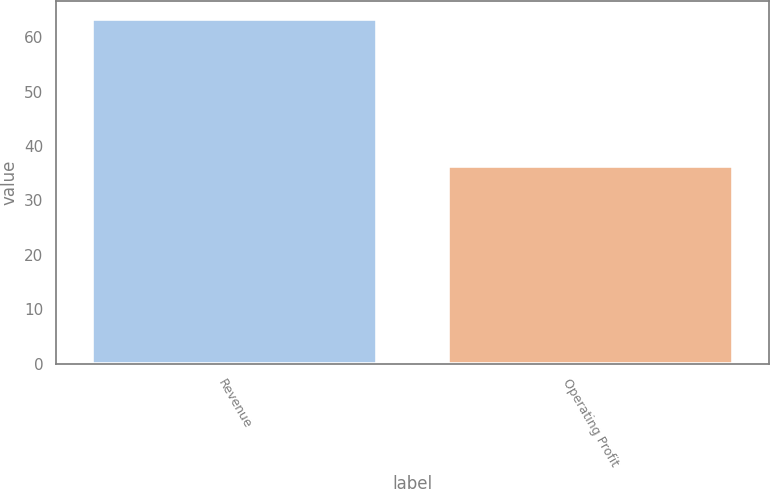Convert chart to OTSL. <chart><loc_0><loc_0><loc_500><loc_500><bar_chart><fcel>Revenue<fcel>Operating Profit<nl><fcel>63.4<fcel>36.4<nl></chart> 